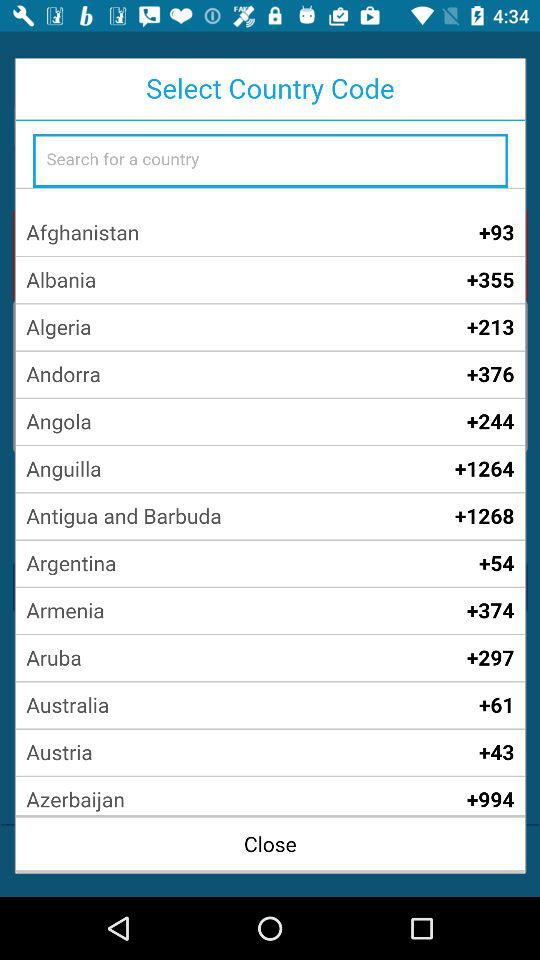What is the country code for Aruba? The country code is +297. 